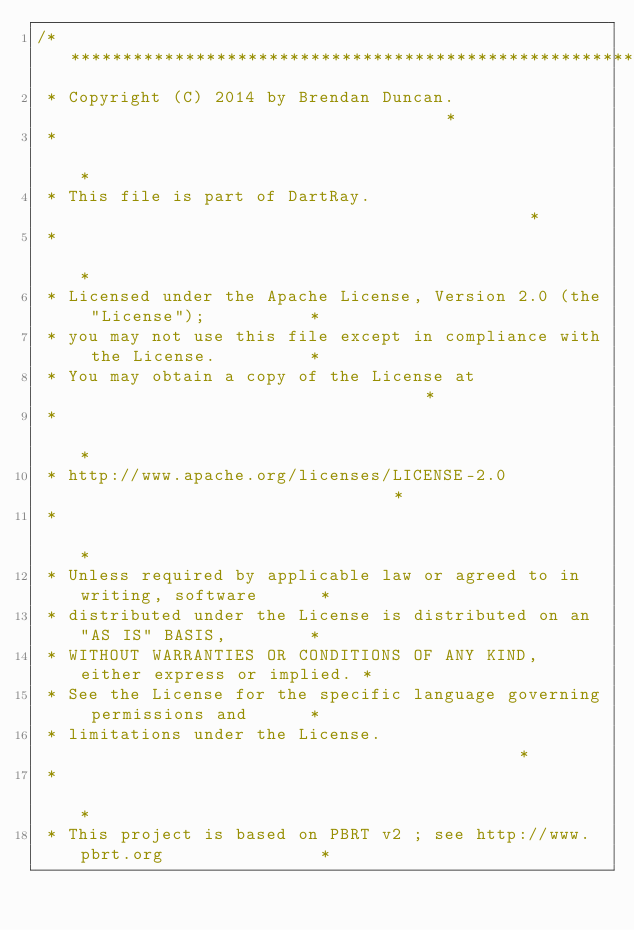Convert code to text. <code><loc_0><loc_0><loc_500><loc_500><_Dart_>/****************************************************************************
 * Copyright (C) 2014 by Brendan Duncan.                                    *
 *                                                                          *
 * This file is part of DartRay.                                            *
 *                                                                          *
 * Licensed under the Apache License, Version 2.0 (the "License");          *
 * you may not use this file except in compliance with the License.         *
 * You may obtain a copy of the License at                                  *
 *                                                                          *
 * http://www.apache.org/licenses/LICENSE-2.0                               *
 *                                                                          *
 * Unless required by applicable law or agreed to in writing, software      *
 * distributed under the License is distributed on an "AS IS" BASIS,        *
 * WITHOUT WARRANTIES OR CONDITIONS OF ANY KIND, either express or implied. *
 * See the License for the specific language governing permissions and      *
 * limitations under the License.                                           *
 *                                                                          *
 * This project is based on PBRT v2 ; see http://www.pbrt.org               *</code> 